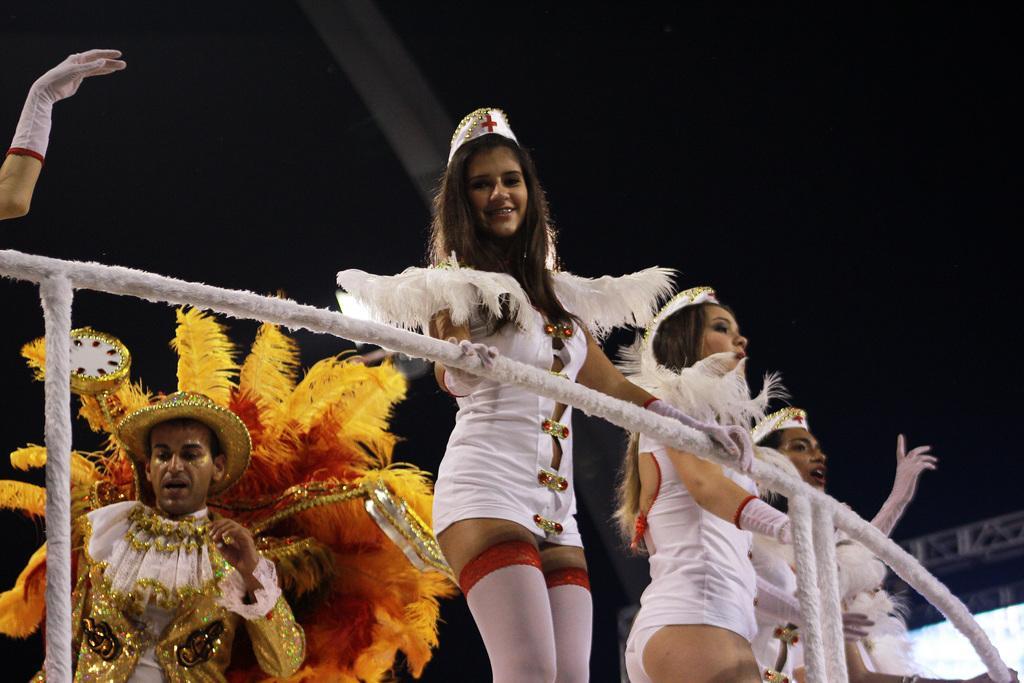Can you describe this image briefly? In this image we can see few people wore costumes. Here we can see rods. There is a dark background. 